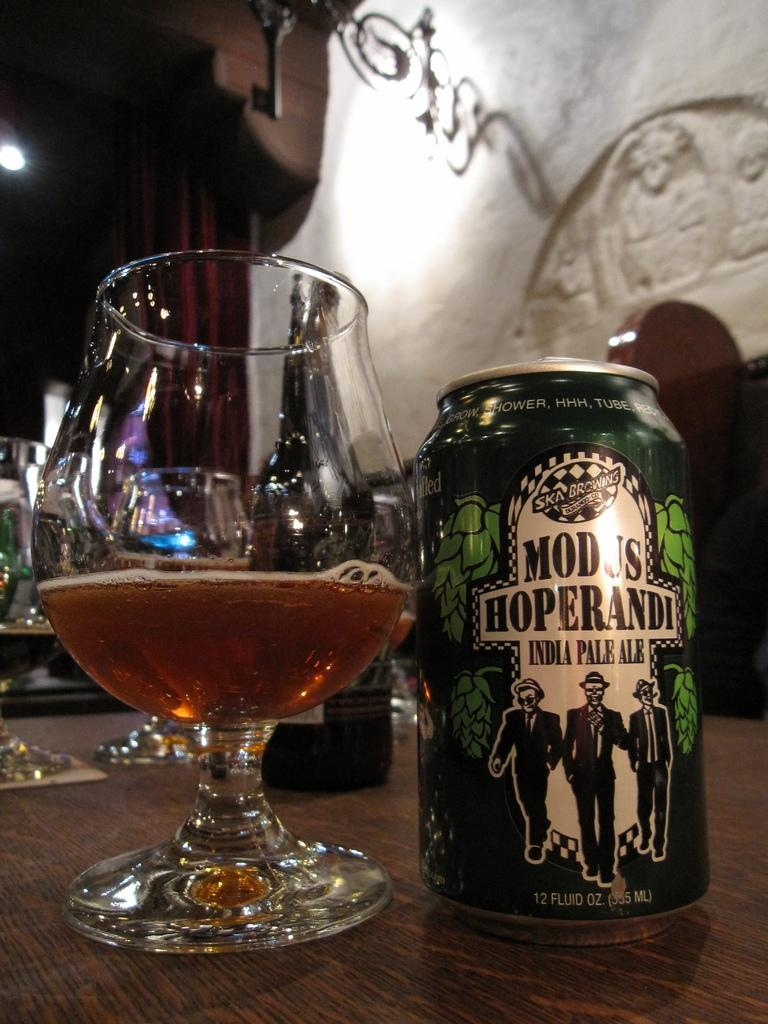What type of containers can be seen in the image? There are glasses and a bottle in the image. What else is present in the image besides the containers? There is a tin can with text and an image in the image. Can you describe the colors of the objects in the background of the image? The objects in the background of the image have brown and white colors. How does the boy interact with his sister in the image? There are no people, including a boy or his sister, present in the image. 